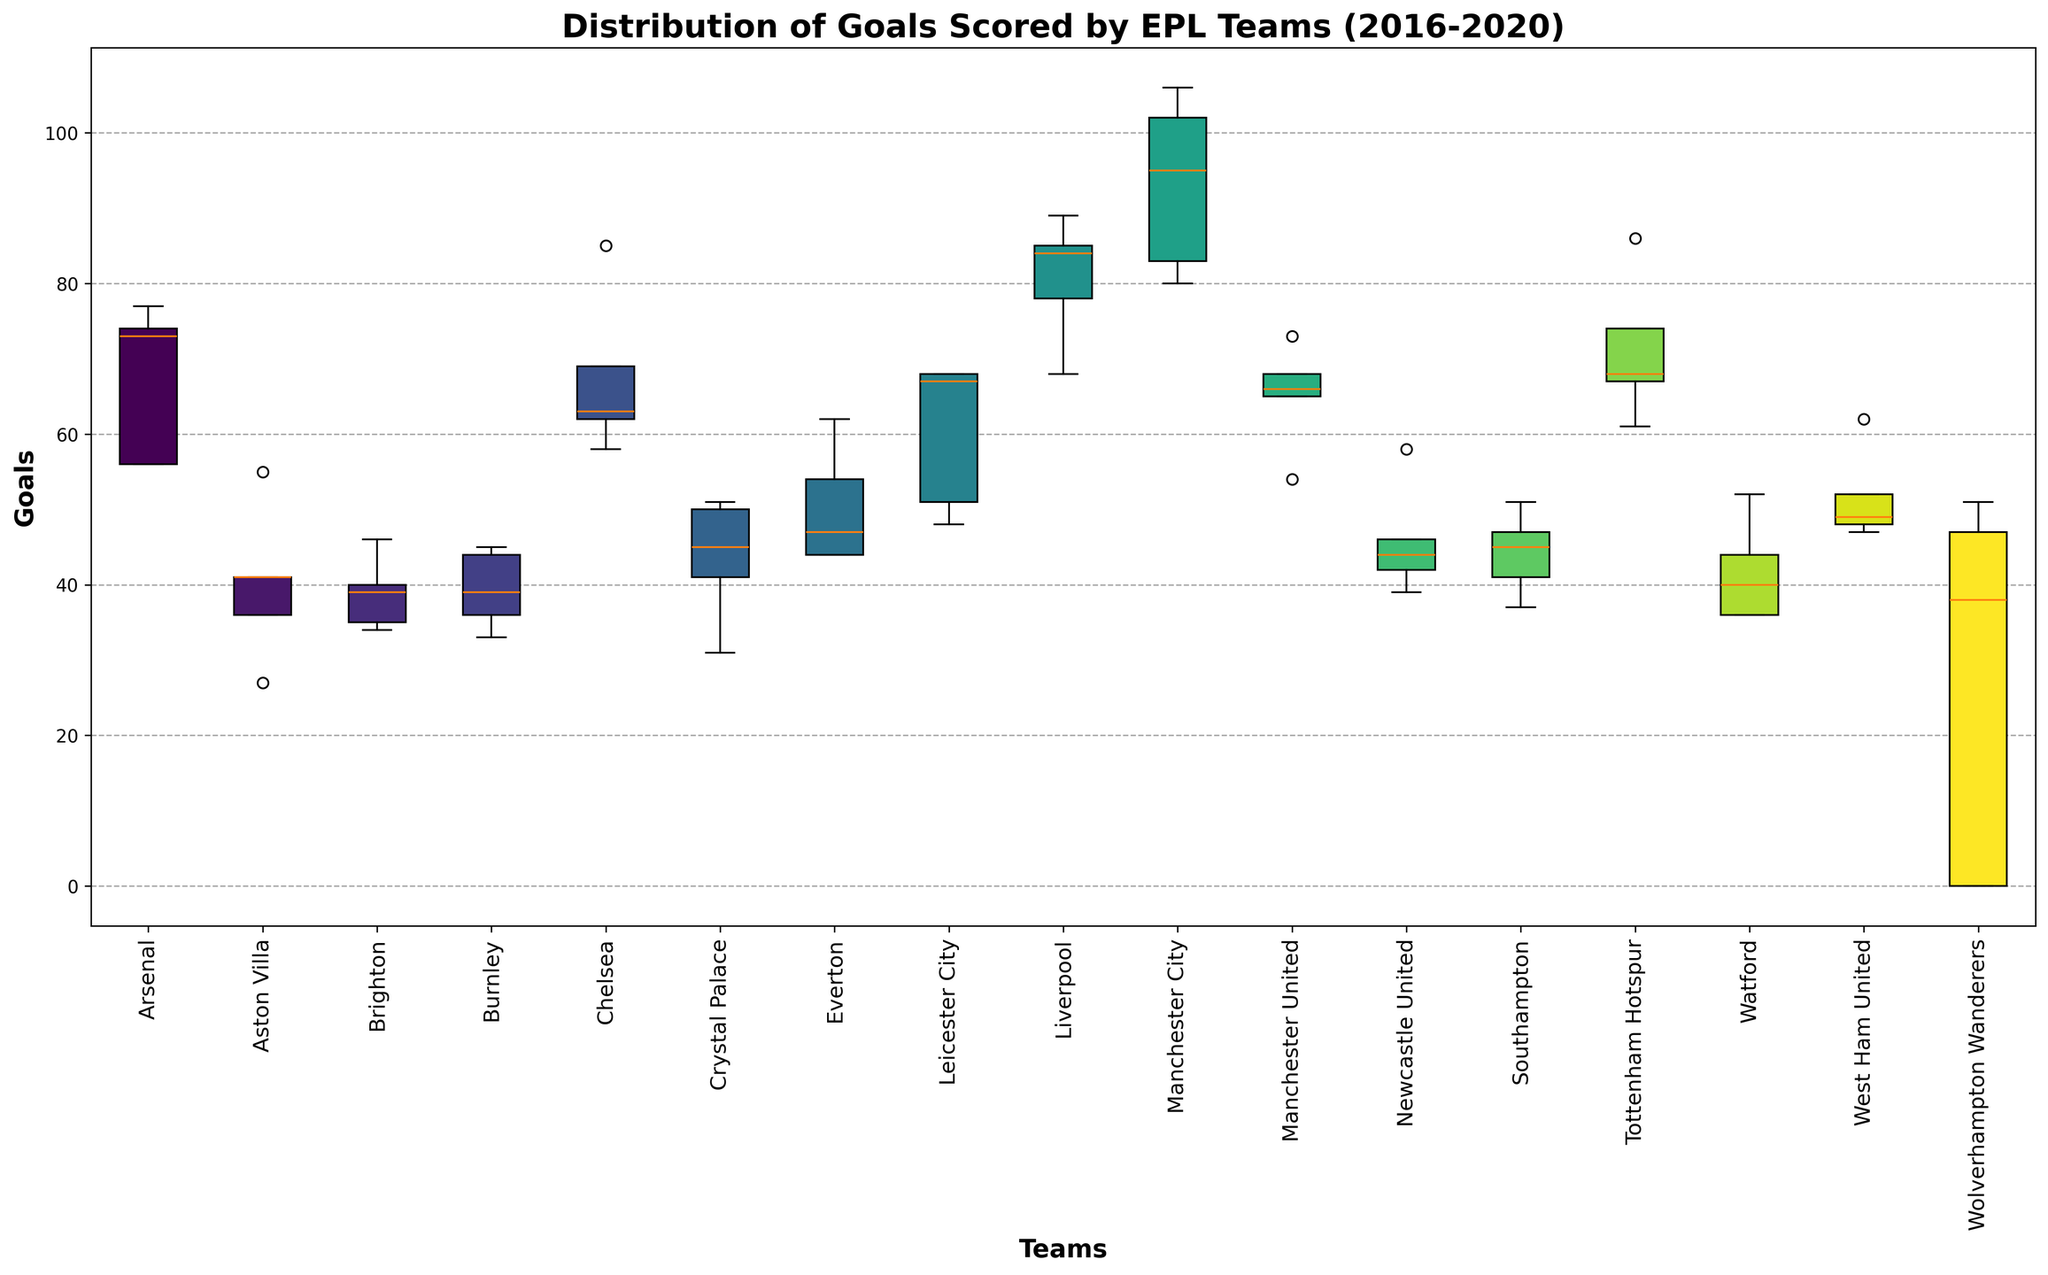What is the team with the highest median number of goals scored from 2016 to 2020? To find the team with the highest median number of goals, identify the team with the highest middle line within the respective boxes on the plot. From visual inspection, Manchester City has the highest median value.
Answer: Manchester City Which team scored exceptionally low or high goals in any season? Look for any box plots that have points significantly outside the boxes (those would be considered outliers). Aston Villa scored exceptionally low in 2016, and Manchester City scored exceptionally high in 2017.
Answer: Aston Villa (2016), Manchester City (2017) Which teams have more consistent goal-scoring records (less variability) over these seasons? Teams with shorter boxes and fewer spread whiskers have more consistent records. Teams like Liverpool and Wolverhampton Wanderers show less variability compared to others.
Answer: Liverpool, Wolverhampton Wanderers Compare the variability of goals scored between Arsenal and Manchester United. Which team shows more variability? Variability can be inferred from the length of the boxes and the whiskers. Arsenal's box plot shows a wider spread than Manchester United's, indicating more variability.
Answer: Arsenal Which team has the most extended range between the minimum and maximum number of goals scored? Identify the team whose whiskers extend the farthest. Manchester City has the widest range, from around 80 to 106 goals.
Answer: Manchester City If we were to rank teams based on their average goals scored per season from highest to lowest, which village would end up in the top three positions? To rank teams, consider both the centers of the boxes (median) and the spread. Based on the box plot, Manchester City, Liverpool, and Tottenham Hotspur appear to have the highest average goals.
Answer: Manchester City, Liverpool, Tottenham Hotspur Which team has the greatest interquartile range (IQR) indicating the spread of the middle 50% of data? The IQR can be inferred from the height of the box itself; the taller the box, the larger the IQR. Manchester United and Burnley show significant spread within their middle 50% data.
Answer: Manchester United, Burnley Observing the box plot, how did Arsenal's goal scoring trend change over the seasons 2016-2020? Look at the position of the median lines and the spread of the data points. Arsenal's goals trend downward, with a fairly consistent range from 2016 to 2018, then a noticeable decline in 2019 and 2020.
Answer: Downward trend Who is more stable in terms of goal scoring, Chelsea or Leicester City? Stability is indicated by the compactness of the box plot and whiskers. Chelsea shows a slightly more condensed box plot and whiskers range than Leicester City.
Answer: Chelsea 